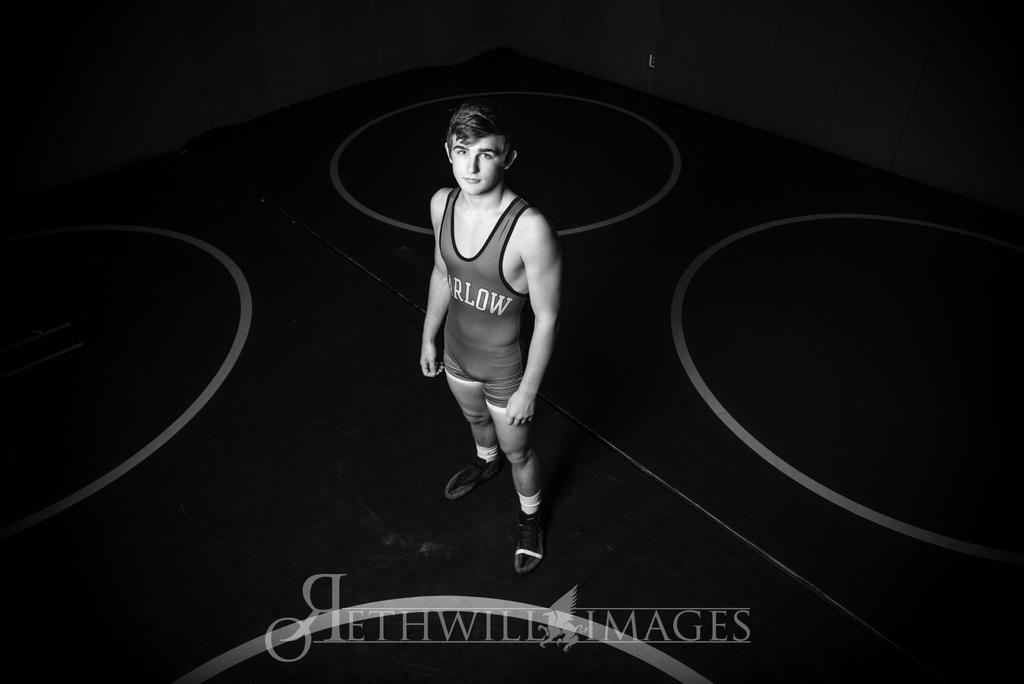What is the color scheme of the image? The image is black and white. Can you describe the person in the image? There is a person standing in the image. What is the pattern on the floor? The floor has white color circles. What is present at the bottom of the image? There is text with a logo at the bottom of the image. What type of rice is being cooked in the image? There is no rice or cooking activity present in the image. Can you describe the person's toe in the image? There is no specific focus on the person's toe in the image; the person's entire body is visible. 